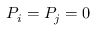Convert formula to latex. <formula><loc_0><loc_0><loc_500><loc_500>P _ { i } = P _ { j } = 0</formula> 